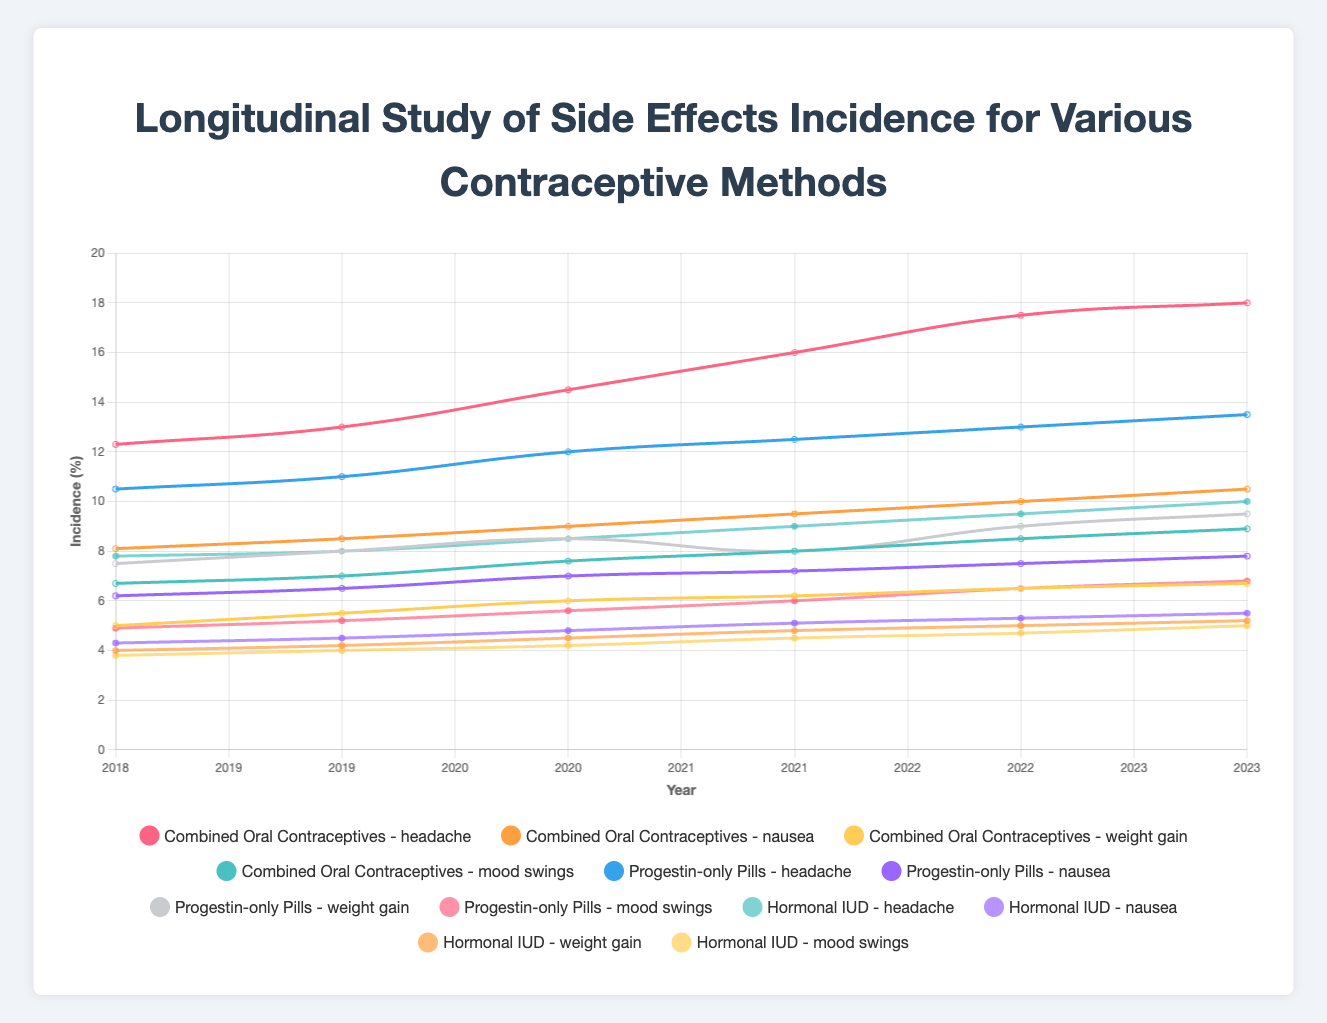What trend can be observed in the incidence of headaches for Combined Oral Contraceptives from 2018 to 2023? Observe the line trend for headaches associated with Combined Oral Contraceptives. The line shows a consistent increase from 12.3% in 2018 to 18.0% in 2023.
Answer: The incidence of headaches increased Which method had the highest incidence of mood swings in 2023? Look at the data points for mood swings in 2023 across all methods. Combined Oral Contraceptives had the highest incidence at 8.9%.
Answer: Combined Oral Contraceptives How much did the incidence of nausea for Progestin-only Pills change from 2018 to 2023? Compare the nausea percentage for Progestin-only Pills in 2018 (6.2%) and 2023 (7.8%). The difference is 7.8% - 6.2% = 1.6%.
Answer: 1.6% Which contraceptive method shows the least increase in weight gain from 2018 to 2023? Analyze the weight gain lines for all methods from 2018 to 2023. Hormonal IUD increases from 4.0% to 5.2%, which is the smallest increase of 1.2%.
Answer: Hormonal IUD Which side effect had the highest variability for Combined Oral Contraceptives across the years? Evaluate the ranges of all side effects. Headaches for Combined Oral Contraceptives range from 12.3% to 18.0% over the years, the highest variability of 5.7%.
Answer: Headache What is the average incidence of nausea for Hormonal IUD across the five years (2018-2023)? Add up the nausea incidences for Hormonal IUD (4.3%, 4.5%, 4.8%, 5.1%, 5.3%, 5.5%) and divide by 6. Total sum = 29.5%, so average is 29.5%/6 = 4.917%.
Answer: 4.917% Compare the headache incidences between Combined Oral Contraceptives and Progestin-only Pills in 2022. Which is higher and by how much? Check headache incidences for both methods in 2022: Combined Oral Contraceptives = 17.5%, Progestin-only Pills = 13.0%. Difference is 17.5% - 13.0% = 4.5%.
Answer: Combined Oral Contraceptives by 4.5% What is the trend in mood swings for Hormonal IUD from 2018 to 2023? Observe the trend line for mood swings in Hormonal IUD from 2018 (3.8%) to 2023 (5.0%). The line shows a slight upward trend.
Answer: Slight upward trend What is the overall change in weight gain incidence for Progestin-only Pills from 2020 to 2023? Compare the weight gain incidences for Progestin-only Pills in 2020 (8.5%) and 2023 (9.5%). The change is 9.5% - 8.5% = 1.0%.
Answer: 1.0% Which method and side effect combination has the lowest incidence in 2019? Look at all incidences in 2019: Hormonal IUD - Nausea at 4.5% is the lowest.
Answer: Hormonal IUD - Nausea 